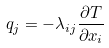Convert formula to latex. <formula><loc_0><loc_0><loc_500><loc_500>q _ { j } = - \lambda _ { i j } \frac { \partial T } { \partial x _ { i } }</formula> 